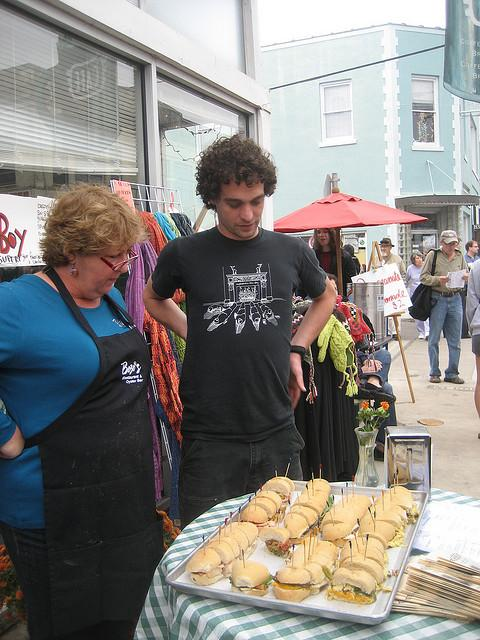What is the tray made from?

Choices:
A) wood
B) plastic
C) steel
D) glass steel 